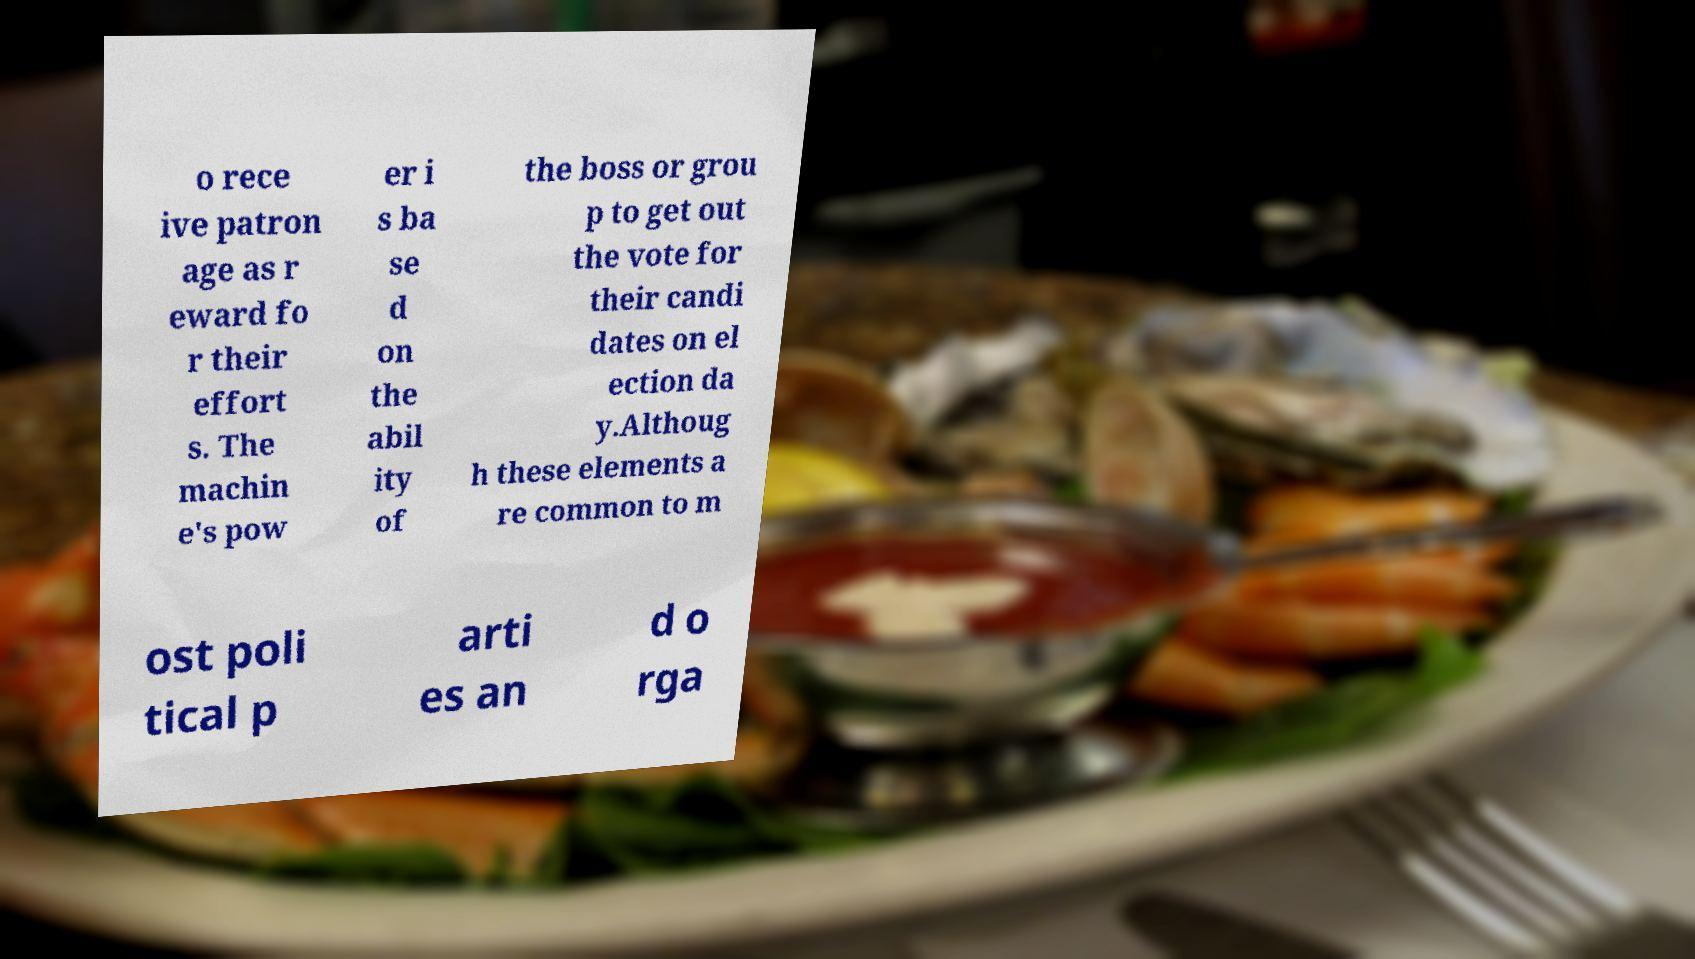There's text embedded in this image that I need extracted. Can you transcribe it verbatim? o rece ive patron age as r eward fo r their effort s. The machin e's pow er i s ba se d on the abil ity of the boss or grou p to get out the vote for their candi dates on el ection da y.Althoug h these elements a re common to m ost poli tical p arti es an d o rga 